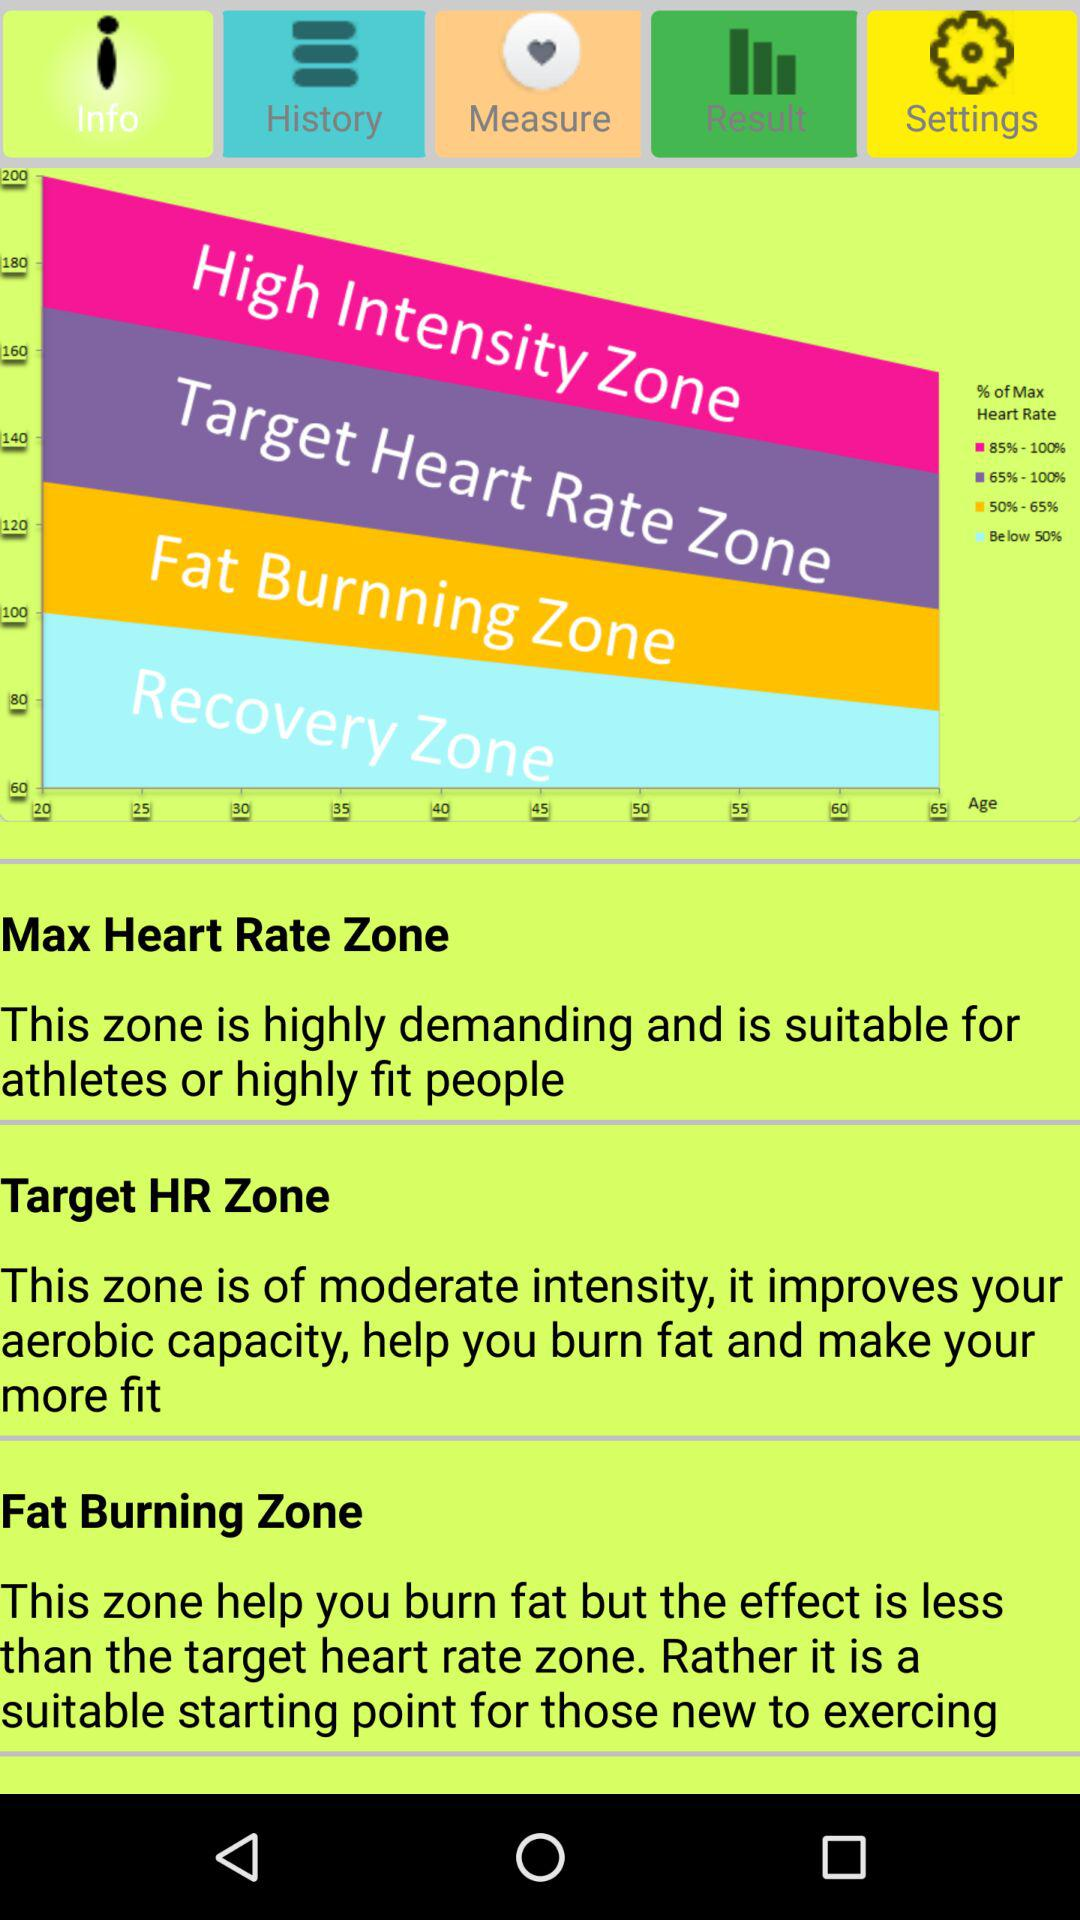What capacity improves under the Target HR Zone? The capacity that improves is aerobic capacity. 